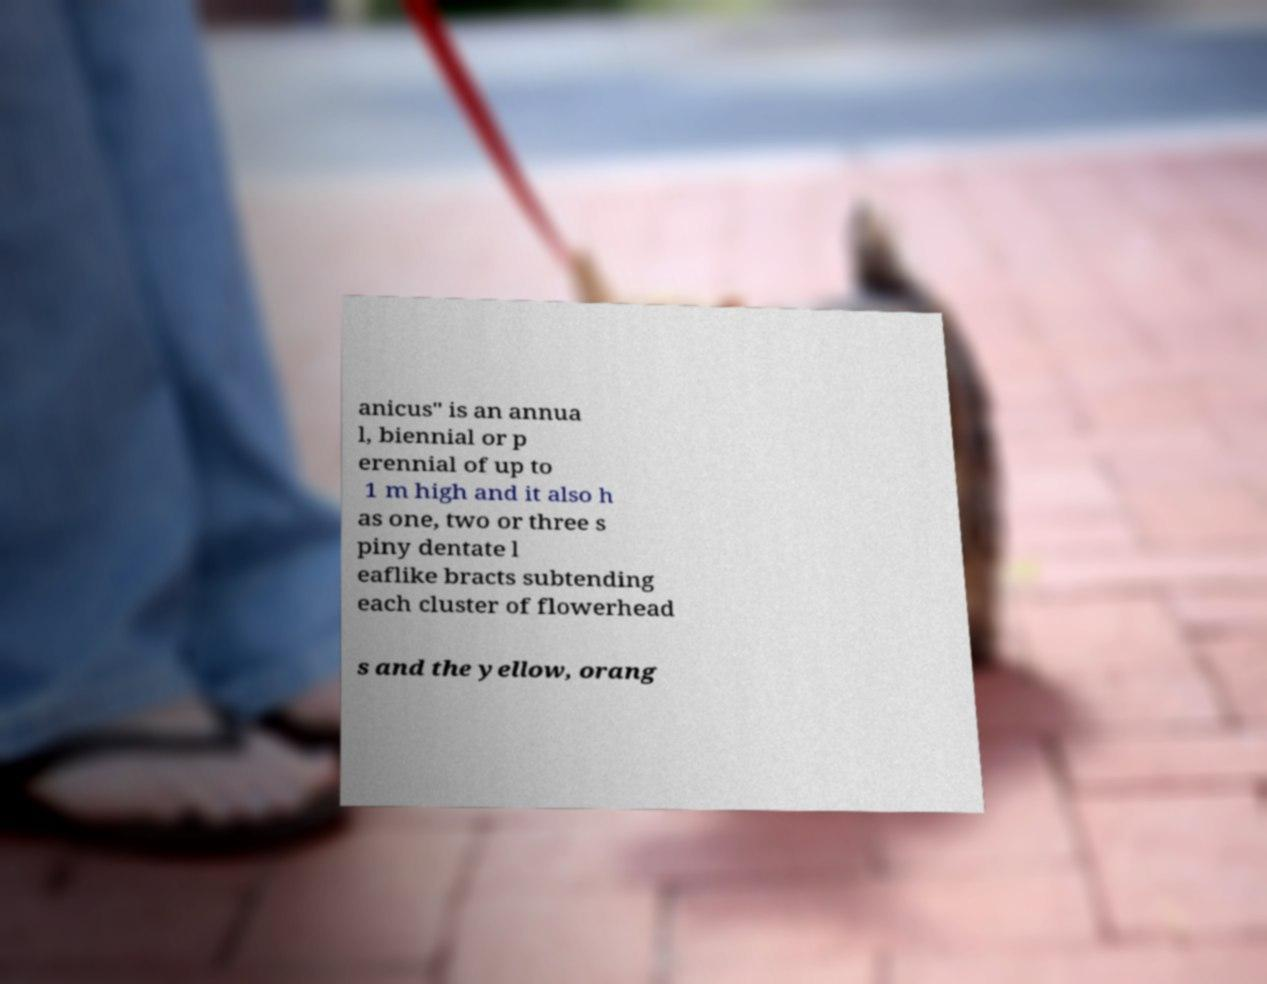What messages or text are displayed in this image? I need them in a readable, typed format. anicus" is an annua l, biennial or p erennial of up to 1 m high and it also h as one, two or three s piny dentate l eaflike bracts subtending each cluster of flowerhead s and the yellow, orang 